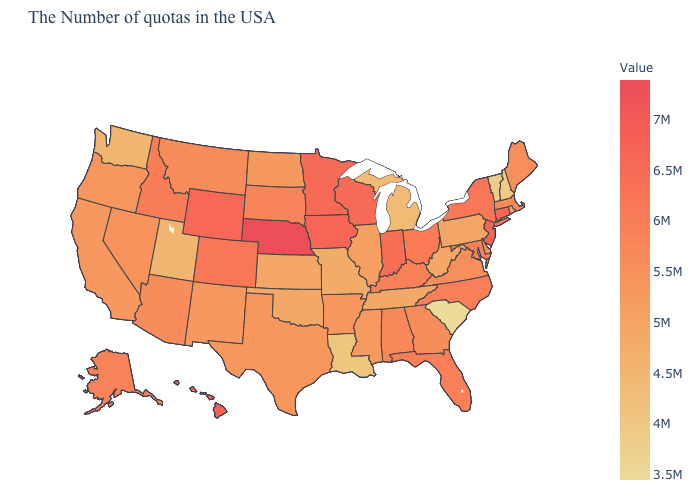Among the states that border Iowa , which have the lowest value?
Answer briefly. Missouri. Is the legend a continuous bar?
Write a very short answer. Yes. Among the states that border Montana , does Wyoming have the lowest value?
Be succinct. No. Does the map have missing data?
Short answer required. No. Which states have the lowest value in the USA?
Be succinct. South Carolina. Which states hav the highest value in the West?
Be succinct. Hawaii. Does Arkansas have the lowest value in the USA?
Concise answer only. No. 